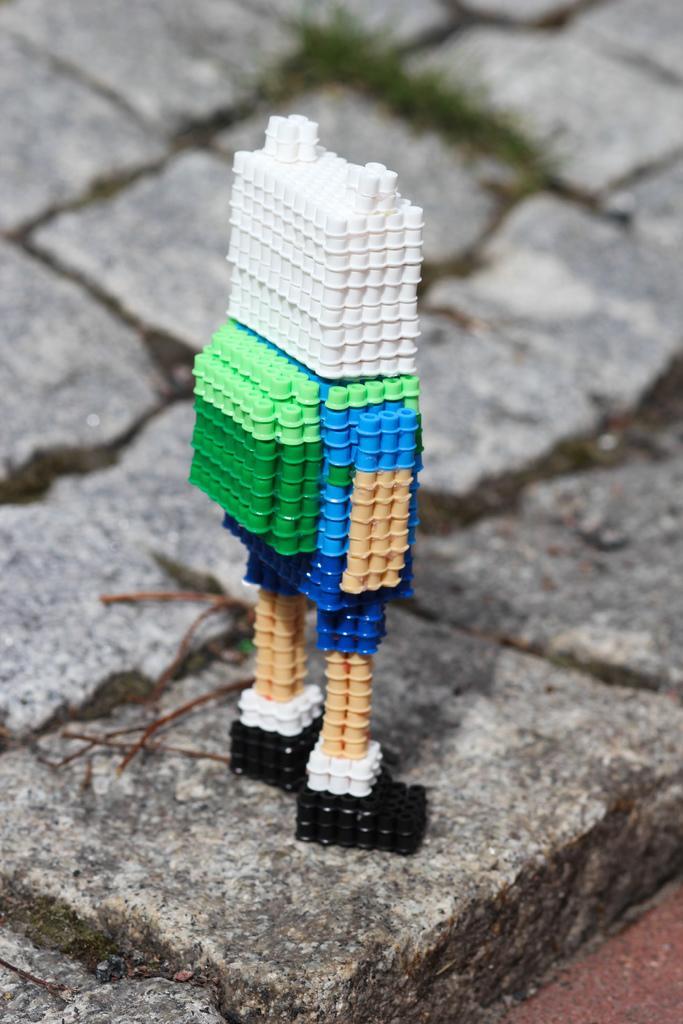Please provide a concise description of this image. It's a toy in the shape of a human on this stone floor. 